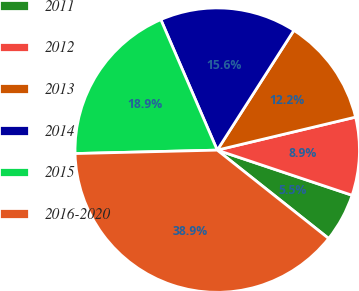<chart> <loc_0><loc_0><loc_500><loc_500><pie_chart><fcel>2011<fcel>2012<fcel>2013<fcel>2014<fcel>2015<fcel>2016-2020<nl><fcel>5.53%<fcel>8.87%<fcel>12.21%<fcel>15.55%<fcel>18.89%<fcel>38.94%<nl></chart> 